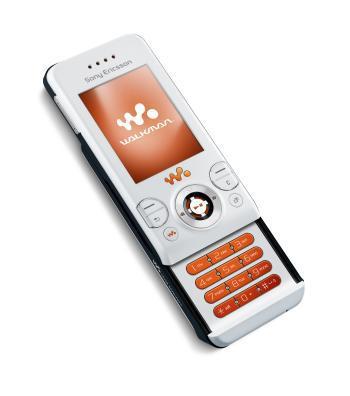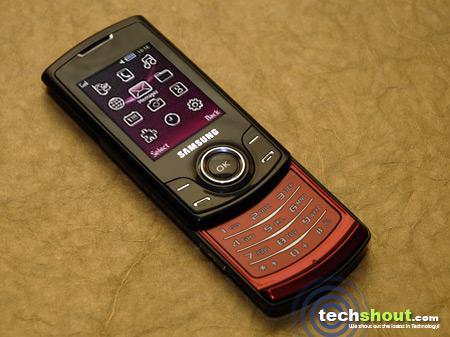The first image is the image on the left, the second image is the image on the right. Analyze the images presented: Is the assertion "A yellow cellphone has a visible black antena in one of the images." valid? Answer yes or no. No. The first image is the image on the left, the second image is the image on the right. Assess this claim about the two images: "One of the cell phones is yellow with a short black antenna.". Correct or not? Answer yes or no. No. 